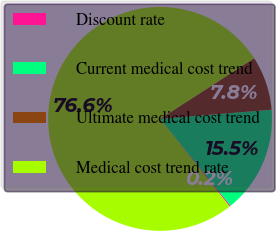<chart> <loc_0><loc_0><loc_500><loc_500><pie_chart><fcel>Discount rate<fcel>Current medical cost trend<fcel>Ultimate medical cost trend<fcel>Medical cost trend rate<nl><fcel>0.17%<fcel>15.45%<fcel>7.81%<fcel>76.56%<nl></chart> 